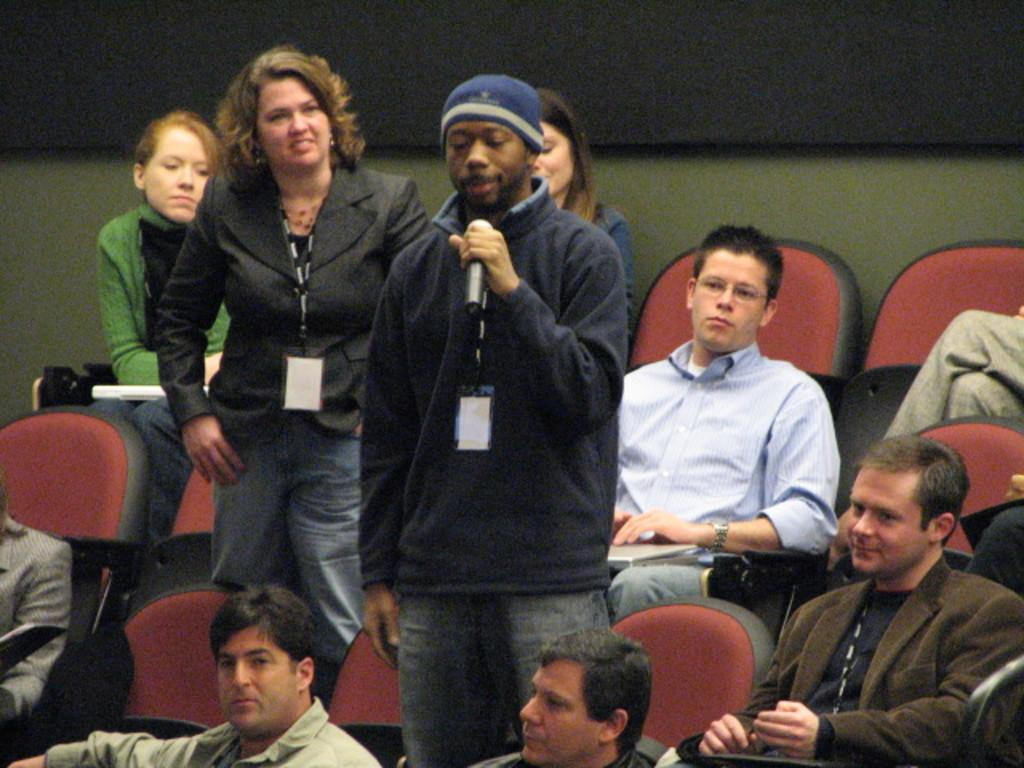Who is the main subject in the image? There is a man in the image. What is the man doing in the image? The man is speaking into a microphone. Are there any other people present in the image? Yes, there are people around the man. What might the people be doing in the image? They might be listening to the man or attending an event. What can be seen in the image that might indicate seating arrangements? There are seats in the image. Can you see any steam coming from the microphone in the image? No, there is no steam visible in the image. Is there a fight or battle taking place in the image? No, there is no fight or battle depicted in the image. 